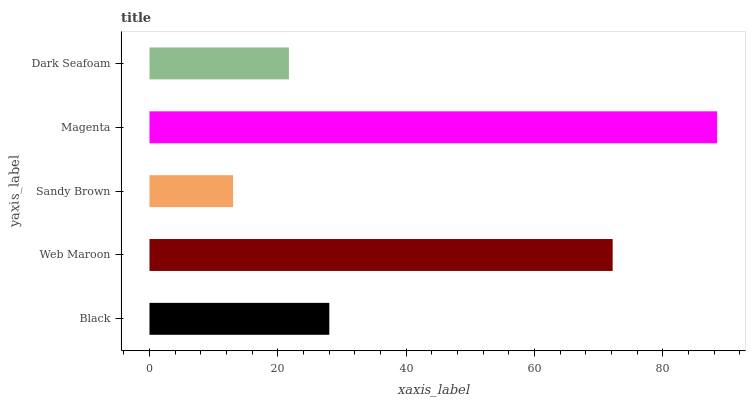Is Sandy Brown the minimum?
Answer yes or no. Yes. Is Magenta the maximum?
Answer yes or no. Yes. Is Web Maroon the minimum?
Answer yes or no. No. Is Web Maroon the maximum?
Answer yes or no. No. Is Web Maroon greater than Black?
Answer yes or no. Yes. Is Black less than Web Maroon?
Answer yes or no. Yes. Is Black greater than Web Maroon?
Answer yes or no. No. Is Web Maroon less than Black?
Answer yes or no. No. Is Black the high median?
Answer yes or no. Yes. Is Black the low median?
Answer yes or no. Yes. Is Dark Seafoam the high median?
Answer yes or no. No. Is Web Maroon the low median?
Answer yes or no. No. 